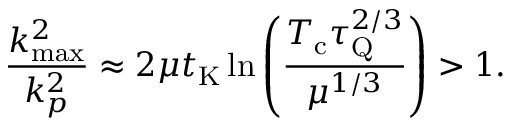<formula> <loc_0><loc_0><loc_500><loc_500>\frac { k _ { \max } ^ { 2 } } { k _ { p } ^ { 2 } } \approx 2 \mu t _ { K } \ln \left ( { \frac { T _ { c } \tau _ { Q } ^ { 2 / 3 } } { \mu ^ { 1 / 3 } } } \right ) > 1 .</formula> 